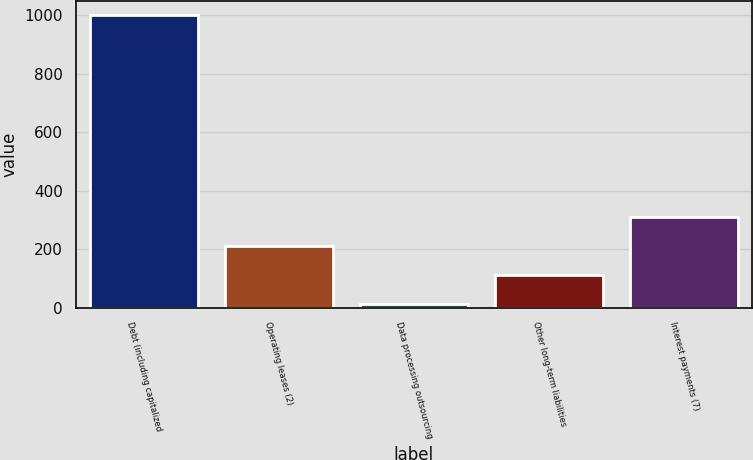<chart> <loc_0><loc_0><loc_500><loc_500><bar_chart><fcel>Debt (including capitalized<fcel>Operating leases (2)<fcel>Data processing outsourcing<fcel>Other long-term liabilities<fcel>Interest payments (7)<nl><fcel>1000<fcel>211.2<fcel>14<fcel>112.6<fcel>309.8<nl></chart> 